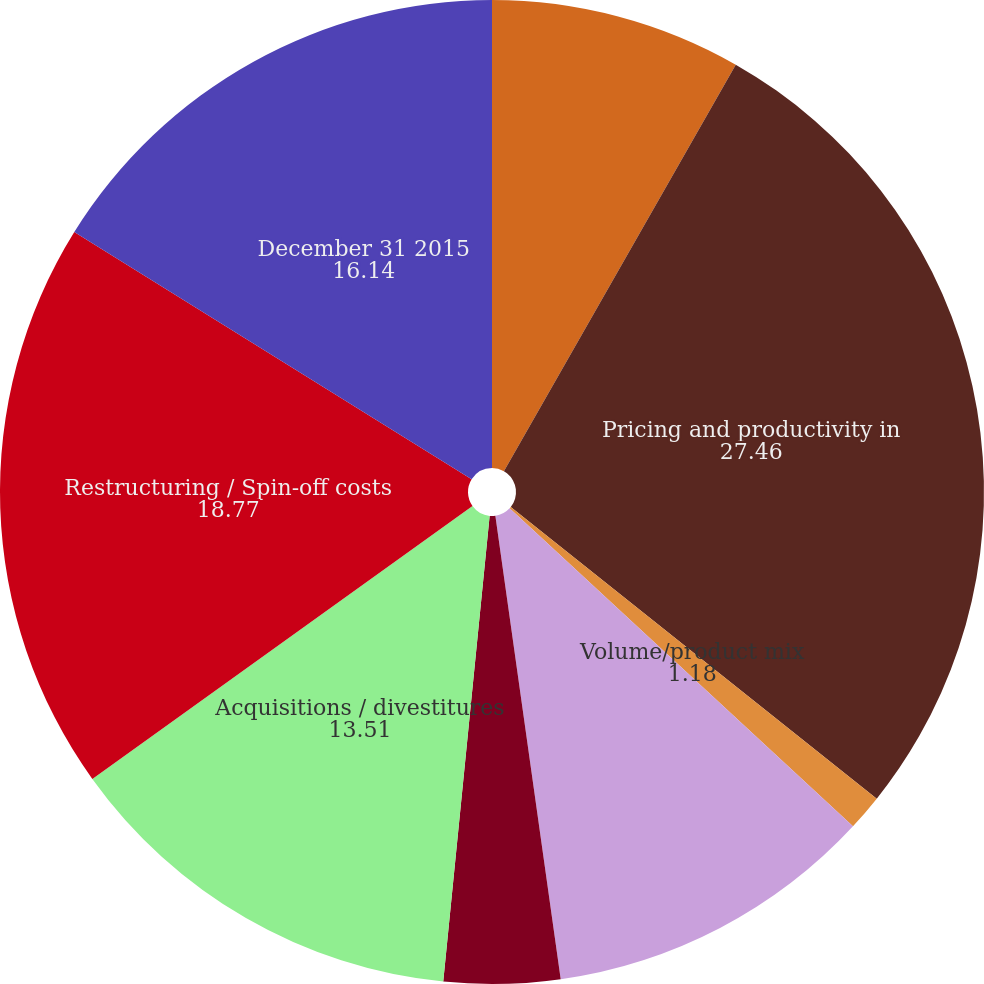Convert chart. <chart><loc_0><loc_0><loc_500><loc_500><pie_chart><fcel>December 31 2014<fcel>Pricing and productivity in<fcel>Volume/product mix<fcel>Currency exchange rates<fcel>Investment spending and other<fcel>Acquisitions / divestitures<fcel>Restructuring / Spin-off costs<fcel>December 31 2015<nl><fcel>8.25%<fcel>27.46%<fcel>1.18%<fcel>10.88%<fcel>3.81%<fcel>13.51%<fcel>18.77%<fcel>16.14%<nl></chart> 